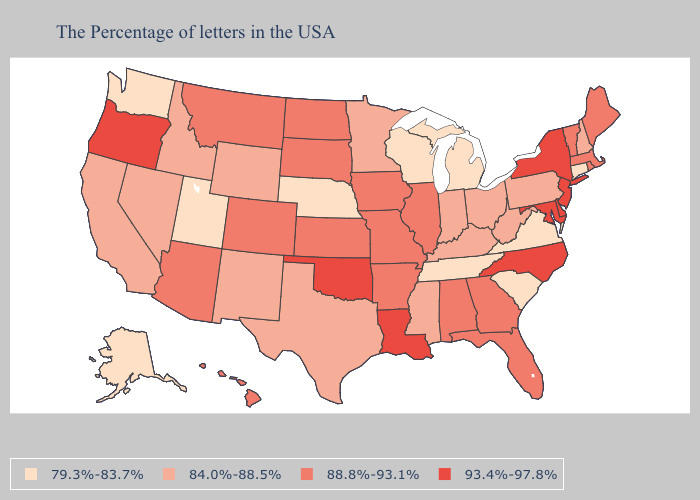Name the states that have a value in the range 84.0%-88.5%?
Concise answer only. New Hampshire, Pennsylvania, West Virginia, Ohio, Kentucky, Indiana, Mississippi, Minnesota, Texas, Wyoming, New Mexico, Idaho, Nevada, California. Does Idaho have the highest value in the USA?
Keep it brief. No. Is the legend a continuous bar?
Be succinct. No. Name the states that have a value in the range 79.3%-83.7%?
Keep it brief. Connecticut, Virginia, South Carolina, Michigan, Tennessee, Wisconsin, Nebraska, Utah, Washington, Alaska. Does the first symbol in the legend represent the smallest category?
Answer briefly. Yes. What is the value of Rhode Island?
Write a very short answer. 88.8%-93.1%. Name the states that have a value in the range 79.3%-83.7%?
Write a very short answer. Connecticut, Virginia, South Carolina, Michigan, Tennessee, Wisconsin, Nebraska, Utah, Washington, Alaska. What is the lowest value in the MidWest?
Answer briefly. 79.3%-83.7%. What is the value of Rhode Island?
Quick response, please. 88.8%-93.1%. Which states hav the highest value in the Northeast?
Answer briefly. New York, New Jersey. What is the value of Utah?
Be succinct. 79.3%-83.7%. Is the legend a continuous bar?
Short answer required. No. What is the value of New Jersey?
Concise answer only. 93.4%-97.8%. Among the states that border Tennessee , which have the lowest value?
Quick response, please. Virginia. What is the value of North Dakota?
Answer briefly. 88.8%-93.1%. 